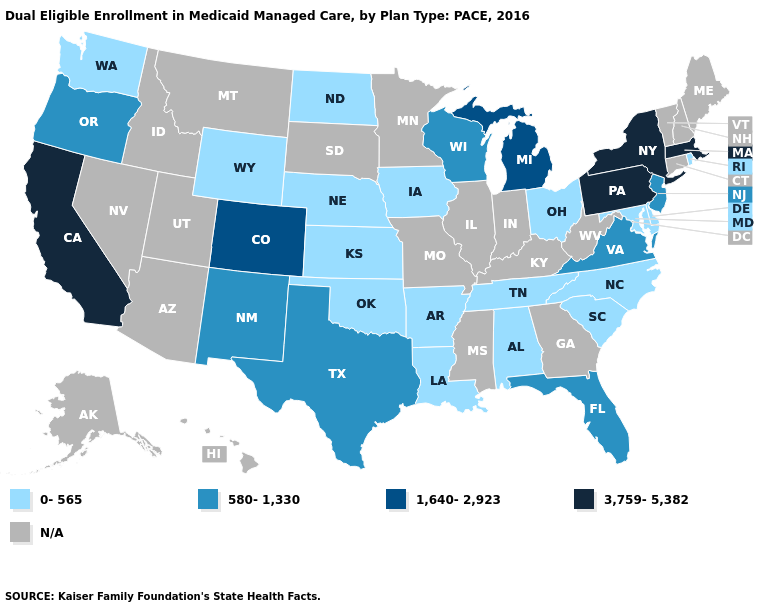What is the highest value in the South ?
Short answer required. 580-1,330. What is the value of Ohio?
Quick response, please. 0-565. Does North Dakota have the lowest value in the USA?
Short answer required. Yes. What is the lowest value in the South?
Concise answer only. 0-565. Does the first symbol in the legend represent the smallest category?
Concise answer only. Yes. Among the states that border Connecticut , which have the highest value?
Quick response, please. Massachusetts, New York. Does the first symbol in the legend represent the smallest category?
Keep it brief. Yes. What is the value of Alabama?
Short answer required. 0-565. Name the states that have a value in the range 0-565?
Keep it brief. Alabama, Arkansas, Delaware, Iowa, Kansas, Louisiana, Maryland, Nebraska, North Carolina, North Dakota, Ohio, Oklahoma, Rhode Island, South Carolina, Tennessee, Washington, Wyoming. Among the states that border Wisconsin , which have the highest value?
Concise answer only. Michigan. Name the states that have a value in the range 580-1,330?
Write a very short answer. Florida, New Jersey, New Mexico, Oregon, Texas, Virginia, Wisconsin. Does the first symbol in the legend represent the smallest category?
Keep it brief. Yes. What is the value of Ohio?
Keep it brief. 0-565. Name the states that have a value in the range 1,640-2,923?
Be succinct. Colorado, Michigan. 